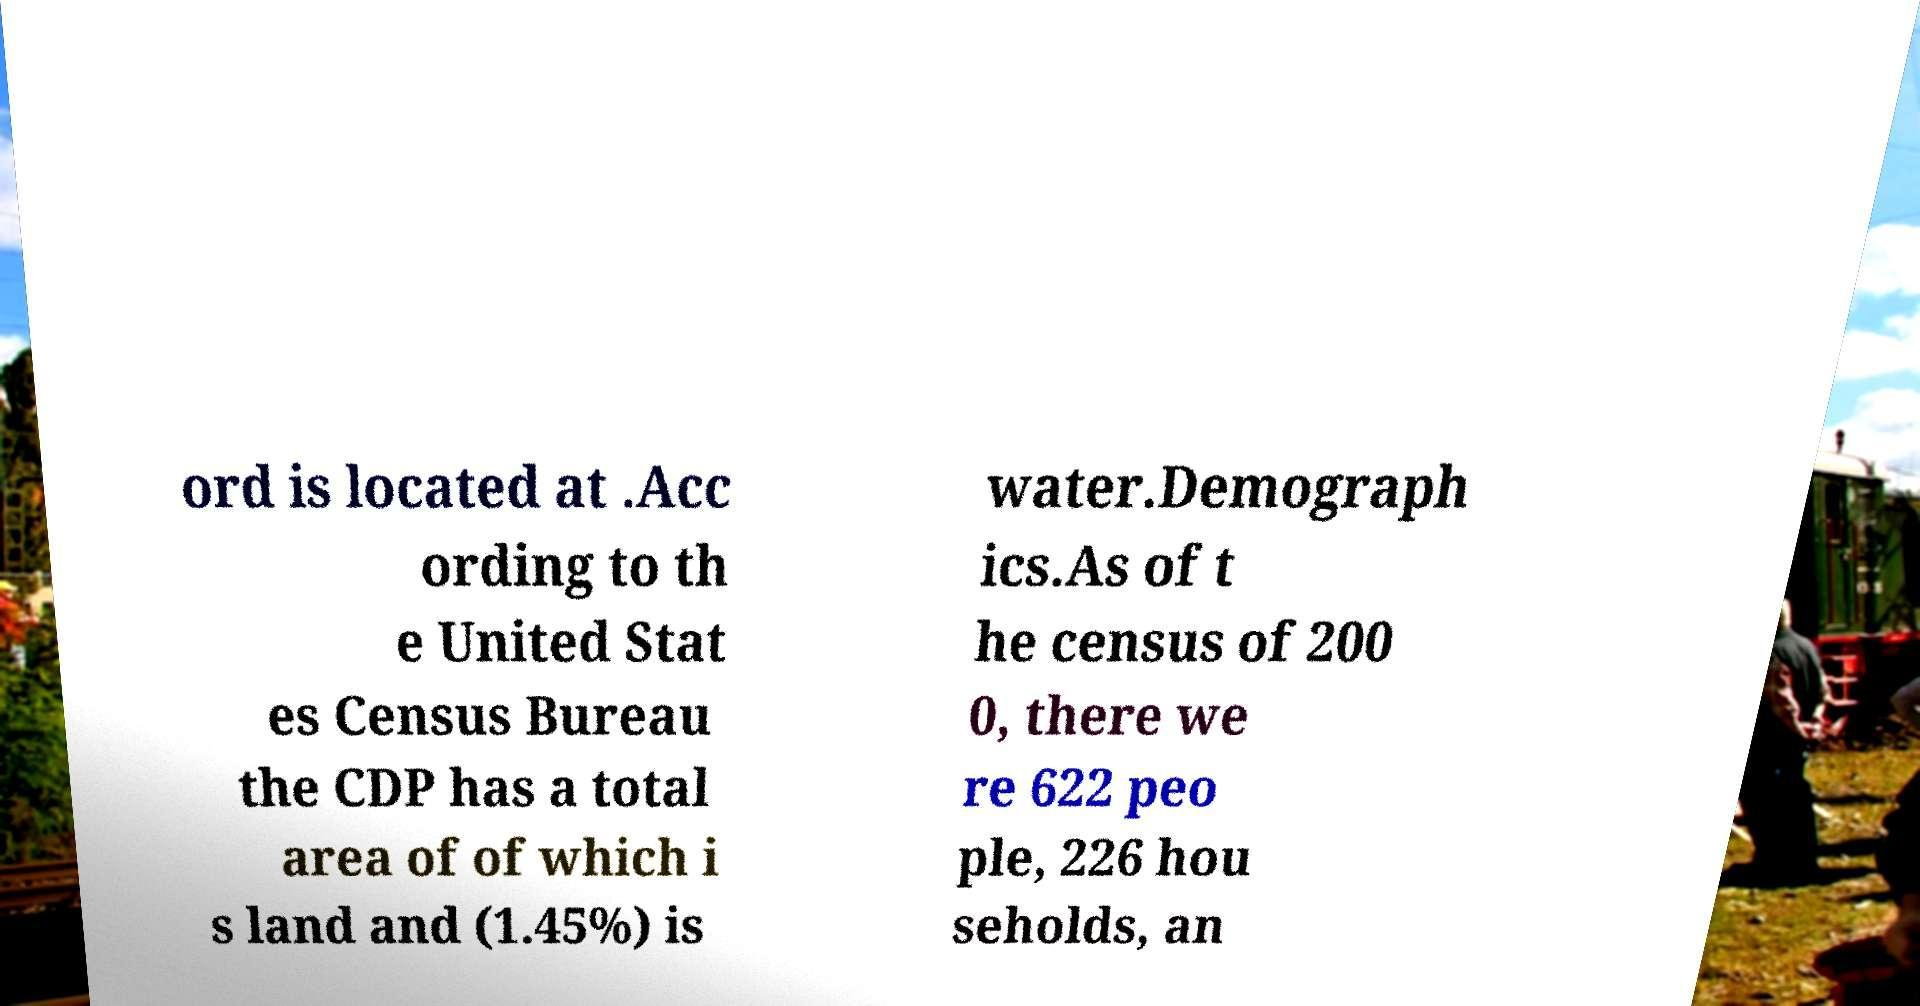For documentation purposes, I need the text within this image transcribed. Could you provide that? ord is located at .Acc ording to th e United Stat es Census Bureau the CDP has a total area of of which i s land and (1.45%) is water.Demograph ics.As of t he census of 200 0, there we re 622 peo ple, 226 hou seholds, an 